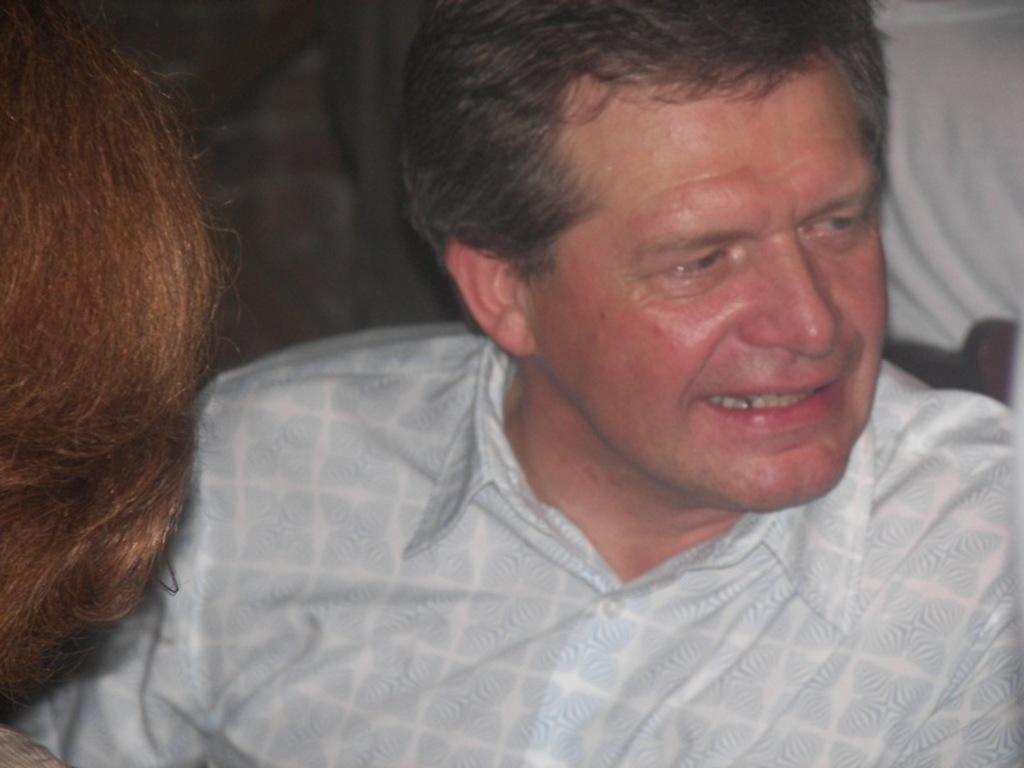Describe this image in one or two sentences. This image is taken indoors. On the left side of the image there is a hair of a person. In the middle of the image a man is sitting on the chair. On the right side of the image there is a person. 